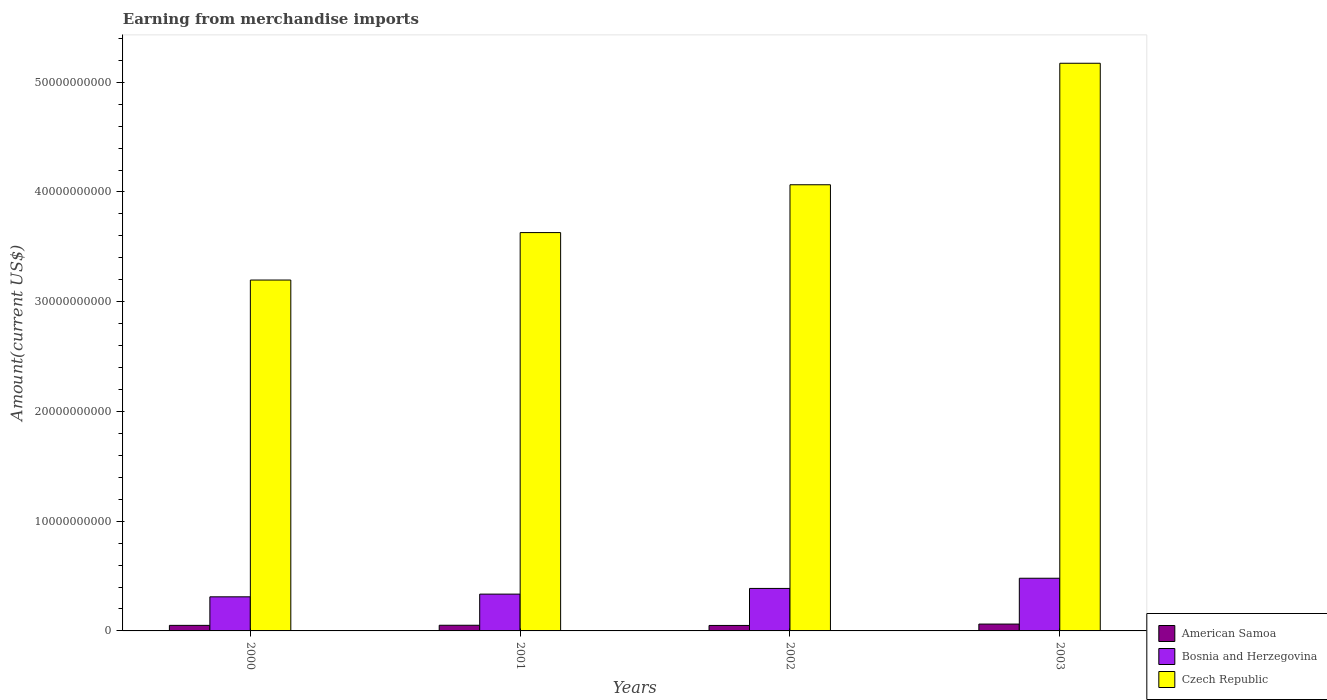How many different coloured bars are there?
Your answer should be very brief. 3. Are the number of bars per tick equal to the number of legend labels?
Give a very brief answer. Yes. How many bars are there on the 3rd tick from the right?
Give a very brief answer. 3. What is the label of the 3rd group of bars from the left?
Your answer should be compact. 2002. In how many cases, is the number of bars for a given year not equal to the number of legend labels?
Keep it short and to the point. 0. What is the amount earned from merchandise imports in Bosnia and Herzegovina in 2003?
Give a very brief answer. 4.80e+09. Across all years, what is the maximum amount earned from merchandise imports in Bosnia and Herzegovina?
Provide a succinct answer. 4.80e+09. Across all years, what is the minimum amount earned from merchandise imports in American Samoa?
Make the answer very short. 4.99e+08. In which year was the amount earned from merchandise imports in Bosnia and Herzegovina maximum?
Provide a short and direct response. 2003. What is the total amount earned from merchandise imports in Bosnia and Herzegovina in the graph?
Ensure brevity in your answer.  1.51e+1. What is the difference between the amount earned from merchandise imports in American Samoa in 2001 and that in 2003?
Your answer should be compact. -1.08e+08. What is the difference between the amount earned from merchandise imports in Bosnia and Herzegovina in 2000 and the amount earned from merchandise imports in Czech Republic in 2003?
Make the answer very short. -4.86e+1. What is the average amount earned from merchandise imports in Czech Republic per year?
Ensure brevity in your answer.  4.02e+1. In the year 2003, what is the difference between the amount earned from merchandise imports in Bosnia and Herzegovina and amount earned from merchandise imports in American Samoa?
Your answer should be very brief. 4.18e+09. What is the ratio of the amount earned from merchandise imports in Czech Republic in 2001 to that in 2002?
Offer a very short reply. 0.89. Is the amount earned from merchandise imports in American Samoa in 2000 less than that in 2002?
Make the answer very short. No. What is the difference between the highest and the second highest amount earned from merchandise imports in Bosnia and Herzegovina?
Ensure brevity in your answer.  9.29e+08. What is the difference between the highest and the lowest amount earned from merchandise imports in Bosnia and Herzegovina?
Offer a terse response. 1.69e+09. In how many years, is the amount earned from merchandise imports in American Samoa greater than the average amount earned from merchandise imports in American Samoa taken over all years?
Provide a short and direct response. 1. Is the sum of the amount earned from merchandise imports in Czech Republic in 2001 and 2002 greater than the maximum amount earned from merchandise imports in Bosnia and Herzegovina across all years?
Make the answer very short. Yes. What does the 1st bar from the left in 2002 represents?
Offer a very short reply. American Samoa. What does the 3rd bar from the right in 2003 represents?
Give a very brief answer. American Samoa. Is it the case that in every year, the sum of the amount earned from merchandise imports in American Samoa and amount earned from merchandise imports in Czech Republic is greater than the amount earned from merchandise imports in Bosnia and Herzegovina?
Provide a short and direct response. Yes. How many bars are there?
Keep it short and to the point. 12. How many years are there in the graph?
Ensure brevity in your answer.  4. What is the difference between two consecutive major ticks on the Y-axis?
Your answer should be very brief. 1.00e+1. Does the graph contain grids?
Make the answer very short. No. Where does the legend appear in the graph?
Ensure brevity in your answer.  Bottom right. How are the legend labels stacked?
Make the answer very short. Vertical. What is the title of the graph?
Your answer should be compact. Earning from merchandise imports. Does "Timor-Leste" appear as one of the legend labels in the graph?
Give a very brief answer. No. What is the label or title of the X-axis?
Your response must be concise. Years. What is the label or title of the Y-axis?
Provide a succinct answer. Amount(current US$). What is the Amount(current US$) in American Samoa in 2000?
Provide a short and direct response. 5.06e+08. What is the Amount(current US$) in Bosnia and Herzegovina in 2000?
Offer a very short reply. 3.11e+09. What is the Amount(current US$) of Czech Republic in 2000?
Provide a succinct answer. 3.20e+1. What is the Amount(current US$) in American Samoa in 2001?
Make the answer very short. 5.16e+08. What is the Amount(current US$) in Bosnia and Herzegovina in 2001?
Make the answer very short. 3.35e+09. What is the Amount(current US$) in Czech Republic in 2001?
Offer a terse response. 3.63e+1. What is the Amount(current US$) in American Samoa in 2002?
Offer a very short reply. 4.99e+08. What is the Amount(current US$) of Bosnia and Herzegovina in 2002?
Give a very brief answer. 3.87e+09. What is the Amount(current US$) of Czech Republic in 2002?
Your answer should be very brief. 4.07e+1. What is the Amount(current US$) of American Samoa in 2003?
Offer a very short reply. 6.24e+08. What is the Amount(current US$) of Bosnia and Herzegovina in 2003?
Provide a succinct answer. 4.80e+09. What is the Amount(current US$) in Czech Republic in 2003?
Ensure brevity in your answer.  5.17e+1. Across all years, what is the maximum Amount(current US$) of American Samoa?
Offer a very short reply. 6.24e+08. Across all years, what is the maximum Amount(current US$) of Bosnia and Herzegovina?
Your answer should be compact. 4.80e+09. Across all years, what is the maximum Amount(current US$) of Czech Republic?
Give a very brief answer. 5.17e+1. Across all years, what is the minimum Amount(current US$) in American Samoa?
Give a very brief answer. 4.99e+08. Across all years, what is the minimum Amount(current US$) of Bosnia and Herzegovina?
Your answer should be compact. 3.11e+09. Across all years, what is the minimum Amount(current US$) of Czech Republic?
Your answer should be compact. 3.20e+1. What is the total Amount(current US$) of American Samoa in the graph?
Your response must be concise. 2.14e+09. What is the total Amount(current US$) of Bosnia and Herzegovina in the graph?
Give a very brief answer. 1.51e+1. What is the total Amount(current US$) of Czech Republic in the graph?
Your answer should be very brief. 1.61e+11. What is the difference between the Amount(current US$) of American Samoa in 2000 and that in 2001?
Give a very brief answer. -9.80e+06. What is the difference between the Amount(current US$) of Bosnia and Herzegovina in 2000 and that in 2001?
Your answer should be compact. -2.47e+08. What is the difference between the Amount(current US$) of Czech Republic in 2000 and that in 2001?
Your answer should be compact. -4.32e+09. What is the difference between the Amount(current US$) in American Samoa in 2000 and that in 2002?
Provide a succinct answer. 6.80e+06. What is the difference between the Amount(current US$) in Bosnia and Herzegovina in 2000 and that in 2002?
Offer a very short reply. -7.65e+08. What is the difference between the Amount(current US$) in Czech Republic in 2000 and that in 2002?
Offer a terse response. -8.68e+09. What is the difference between the Amount(current US$) of American Samoa in 2000 and that in 2003?
Give a very brief answer. -1.18e+08. What is the difference between the Amount(current US$) in Bosnia and Herzegovina in 2000 and that in 2003?
Offer a terse response. -1.69e+09. What is the difference between the Amount(current US$) of Czech Republic in 2000 and that in 2003?
Offer a very short reply. -1.98e+1. What is the difference between the Amount(current US$) of American Samoa in 2001 and that in 2002?
Make the answer very short. 1.66e+07. What is the difference between the Amount(current US$) of Bosnia and Herzegovina in 2001 and that in 2002?
Offer a very short reply. -5.18e+08. What is the difference between the Amount(current US$) in Czech Republic in 2001 and that in 2002?
Make the answer very short. -4.36e+09. What is the difference between the Amount(current US$) of American Samoa in 2001 and that in 2003?
Your response must be concise. -1.08e+08. What is the difference between the Amount(current US$) of Bosnia and Herzegovina in 2001 and that in 2003?
Provide a succinct answer. -1.45e+09. What is the difference between the Amount(current US$) in Czech Republic in 2001 and that in 2003?
Provide a short and direct response. -1.54e+1. What is the difference between the Amount(current US$) in American Samoa in 2002 and that in 2003?
Your answer should be compact. -1.25e+08. What is the difference between the Amount(current US$) of Bosnia and Herzegovina in 2002 and that in 2003?
Give a very brief answer. -9.29e+08. What is the difference between the Amount(current US$) of Czech Republic in 2002 and that in 2003?
Make the answer very short. -1.11e+1. What is the difference between the Amount(current US$) in American Samoa in 2000 and the Amount(current US$) in Bosnia and Herzegovina in 2001?
Your answer should be very brief. -2.85e+09. What is the difference between the Amount(current US$) in American Samoa in 2000 and the Amount(current US$) in Czech Republic in 2001?
Provide a short and direct response. -3.58e+1. What is the difference between the Amount(current US$) of Bosnia and Herzegovina in 2000 and the Amount(current US$) of Czech Republic in 2001?
Your answer should be compact. -3.32e+1. What is the difference between the Amount(current US$) in American Samoa in 2000 and the Amount(current US$) in Bosnia and Herzegovina in 2002?
Your response must be concise. -3.37e+09. What is the difference between the Amount(current US$) of American Samoa in 2000 and the Amount(current US$) of Czech Republic in 2002?
Ensure brevity in your answer.  -4.02e+1. What is the difference between the Amount(current US$) of Bosnia and Herzegovina in 2000 and the Amount(current US$) of Czech Republic in 2002?
Offer a terse response. -3.75e+1. What is the difference between the Amount(current US$) in American Samoa in 2000 and the Amount(current US$) in Bosnia and Herzegovina in 2003?
Ensure brevity in your answer.  -4.30e+09. What is the difference between the Amount(current US$) in American Samoa in 2000 and the Amount(current US$) in Czech Republic in 2003?
Your answer should be very brief. -5.12e+1. What is the difference between the Amount(current US$) in Bosnia and Herzegovina in 2000 and the Amount(current US$) in Czech Republic in 2003?
Make the answer very short. -4.86e+1. What is the difference between the Amount(current US$) in American Samoa in 2001 and the Amount(current US$) in Bosnia and Herzegovina in 2002?
Give a very brief answer. -3.36e+09. What is the difference between the Amount(current US$) in American Samoa in 2001 and the Amount(current US$) in Czech Republic in 2002?
Keep it short and to the point. -4.01e+1. What is the difference between the Amount(current US$) in Bosnia and Herzegovina in 2001 and the Amount(current US$) in Czech Republic in 2002?
Offer a very short reply. -3.73e+1. What is the difference between the Amount(current US$) of American Samoa in 2001 and the Amount(current US$) of Bosnia and Herzegovina in 2003?
Your response must be concise. -4.29e+09. What is the difference between the Amount(current US$) of American Samoa in 2001 and the Amount(current US$) of Czech Republic in 2003?
Keep it short and to the point. -5.12e+1. What is the difference between the Amount(current US$) in Bosnia and Herzegovina in 2001 and the Amount(current US$) in Czech Republic in 2003?
Keep it short and to the point. -4.84e+1. What is the difference between the Amount(current US$) in American Samoa in 2002 and the Amount(current US$) in Bosnia and Herzegovina in 2003?
Offer a very short reply. -4.30e+09. What is the difference between the Amount(current US$) of American Samoa in 2002 and the Amount(current US$) of Czech Republic in 2003?
Your answer should be compact. -5.12e+1. What is the difference between the Amount(current US$) of Bosnia and Herzegovina in 2002 and the Amount(current US$) of Czech Republic in 2003?
Keep it short and to the point. -4.79e+1. What is the average Amount(current US$) in American Samoa per year?
Give a very brief answer. 5.36e+08. What is the average Amount(current US$) of Bosnia and Herzegovina per year?
Give a very brief answer. 3.78e+09. What is the average Amount(current US$) of Czech Republic per year?
Give a very brief answer. 4.02e+1. In the year 2000, what is the difference between the Amount(current US$) in American Samoa and Amount(current US$) in Bosnia and Herzegovina?
Keep it short and to the point. -2.60e+09. In the year 2000, what is the difference between the Amount(current US$) in American Samoa and Amount(current US$) in Czech Republic?
Keep it short and to the point. -3.15e+1. In the year 2000, what is the difference between the Amount(current US$) of Bosnia and Herzegovina and Amount(current US$) of Czech Republic?
Make the answer very short. -2.89e+1. In the year 2001, what is the difference between the Amount(current US$) of American Samoa and Amount(current US$) of Bosnia and Herzegovina?
Give a very brief answer. -2.84e+09. In the year 2001, what is the difference between the Amount(current US$) of American Samoa and Amount(current US$) of Czech Republic?
Offer a very short reply. -3.58e+1. In the year 2001, what is the difference between the Amount(current US$) in Bosnia and Herzegovina and Amount(current US$) in Czech Republic?
Your answer should be very brief. -3.29e+1. In the year 2002, what is the difference between the Amount(current US$) of American Samoa and Amount(current US$) of Bosnia and Herzegovina?
Offer a very short reply. -3.37e+09. In the year 2002, what is the difference between the Amount(current US$) in American Samoa and Amount(current US$) in Czech Republic?
Your answer should be compact. -4.02e+1. In the year 2002, what is the difference between the Amount(current US$) of Bosnia and Herzegovina and Amount(current US$) of Czech Republic?
Make the answer very short. -3.68e+1. In the year 2003, what is the difference between the Amount(current US$) of American Samoa and Amount(current US$) of Bosnia and Herzegovina?
Give a very brief answer. -4.18e+09. In the year 2003, what is the difference between the Amount(current US$) in American Samoa and Amount(current US$) in Czech Republic?
Provide a short and direct response. -5.11e+1. In the year 2003, what is the difference between the Amount(current US$) of Bosnia and Herzegovina and Amount(current US$) of Czech Republic?
Your answer should be very brief. -4.69e+1. What is the ratio of the Amount(current US$) of American Samoa in 2000 to that in 2001?
Provide a short and direct response. 0.98. What is the ratio of the Amount(current US$) of Bosnia and Herzegovina in 2000 to that in 2001?
Offer a very short reply. 0.93. What is the ratio of the Amount(current US$) of Czech Republic in 2000 to that in 2001?
Give a very brief answer. 0.88. What is the ratio of the Amount(current US$) in American Samoa in 2000 to that in 2002?
Your answer should be compact. 1.01. What is the ratio of the Amount(current US$) of Bosnia and Herzegovina in 2000 to that in 2002?
Provide a short and direct response. 0.8. What is the ratio of the Amount(current US$) in Czech Republic in 2000 to that in 2002?
Your answer should be very brief. 0.79. What is the ratio of the Amount(current US$) of American Samoa in 2000 to that in 2003?
Make the answer very short. 0.81. What is the ratio of the Amount(current US$) in Bosnia and Herzegovina in 2000 to that in 2003?
Give a very brief answer. 0.65. What is the ratio of the Amount(current US$) in Czech Republic in 2000 to that in 2003?
Make the answer very short. 0.62. What is the ratio of the Amount(current US$) in Bosnia and Herzegovina in 2001 to that in 2002?
Give a very brief answer. 0.87. What is the ratio of the Amount(current US$) in Czech Republic in 2001 to that in 2002?
Keep it short and to the point. 0.89. What is the ratio of the Amount(current US$) of American Samoa in 2001 to that in 2003?
Your answer should be very brief. 0.83. What is the ratio of the Amount(current US$) of Bosnia and Herzegovina in 2001 to that in 2003?
Make the answer very short. 0.7. What is the ratio of the Amount(current US$) in Czech Republic in 2001 to that in 2003?
Give a very brief answer. 0.7. What is the ratio of the Amount(current US$) of American Samoa in 2002 to that in 2003?
Give a very brief answer. 0.8. What is the ratio of the Amount(current US$) in Bosnia and Herzegovina in 2002 to that in 2003?
Your answer should be compact. 0.81. What is the ratio of the Amount(current US$) in Czech Republic in 2002 to that in 2003?
Ensure brevity in your answer.  0.79. What is the difference between the highest and the second highest Amount(current US$) of American Samoa?
Make the answer very short. 1.08e+08. What is the difference between the highest and the second highest Amount(current US$) of Bosnia and Herzegovina?
Provide a succinct answer. 9.29e+08. What is the difference between the highest and the second highest Amount(current US$) in Czech Republic?
Keep it short and to the point. 1.11e+1. What is the difference between the highest and the lowest Amount(current US$) of American Samoa?
Keep it short and to the point. 1.25e+08. What is the difference between the highest and the lowest Amount(current US$) in Bosnia and Herzegovina?
Offer a terse response. 1.69e+09. What is the difference between the highest and the lowest Amount(current US$) in Czech Republic?
Your response must be concise. 1.98e+1. 